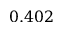<formula> <loc_0><loc_0><loc_500><loc_500>0 . 4 0 2</formula> 